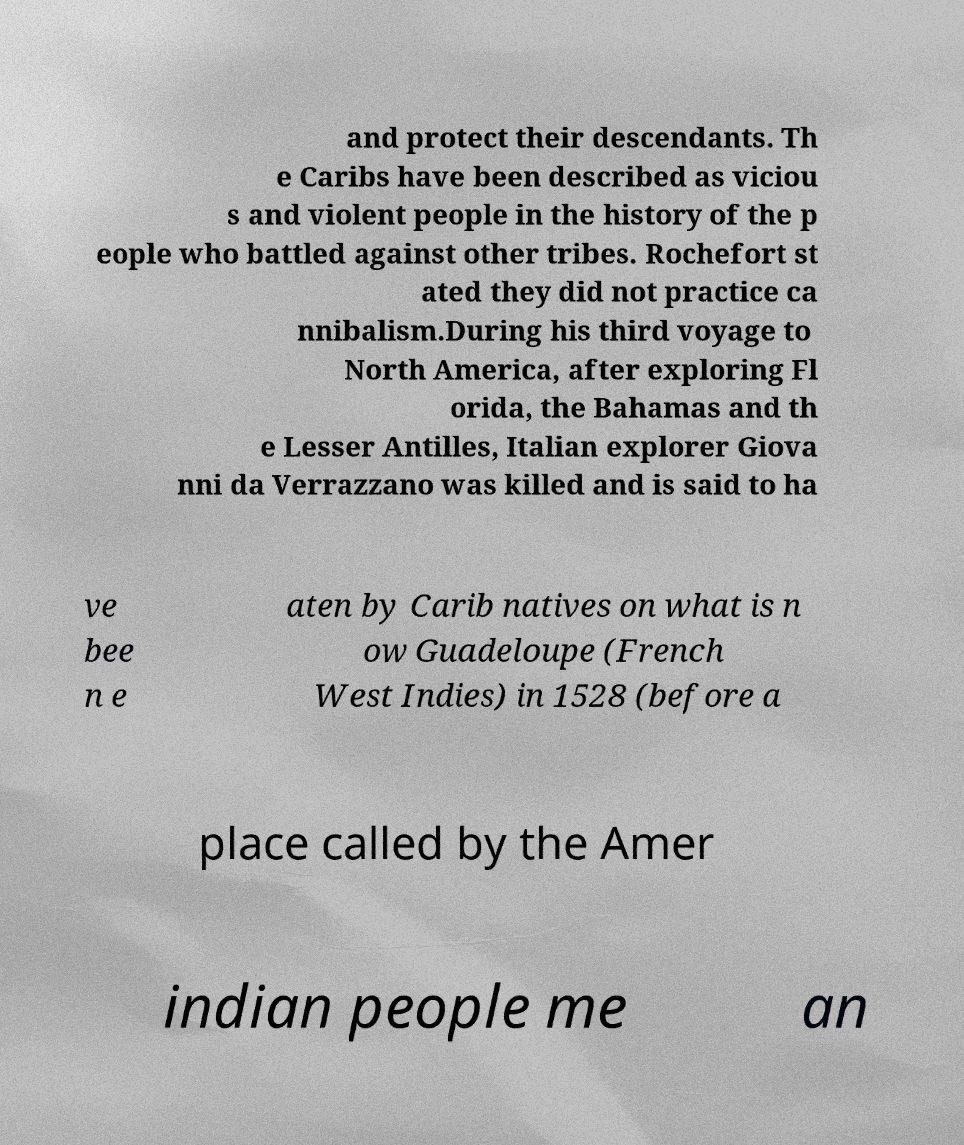Can you read and provide the text displayed in the image?This photo seems to have some interesting text. Can you extract and type it out for me? and protect their descendants. Th e Caribs have been described as viciou s and violent people in the history of the p eople who battled against other tribes. Rochefort st ated they did not practice ca nnibalism.During his third voyage to North America, after exploring Fl orida, the Bahamas and th e Lesser Antilles, Italian explorer Giova nni da Verrazzano was killed and is said to ha ve bee n e aten by Carib natives on what is n ow Guadeloupe (French West Indies) in 1528 (before a place called by the Amer indian people me an 